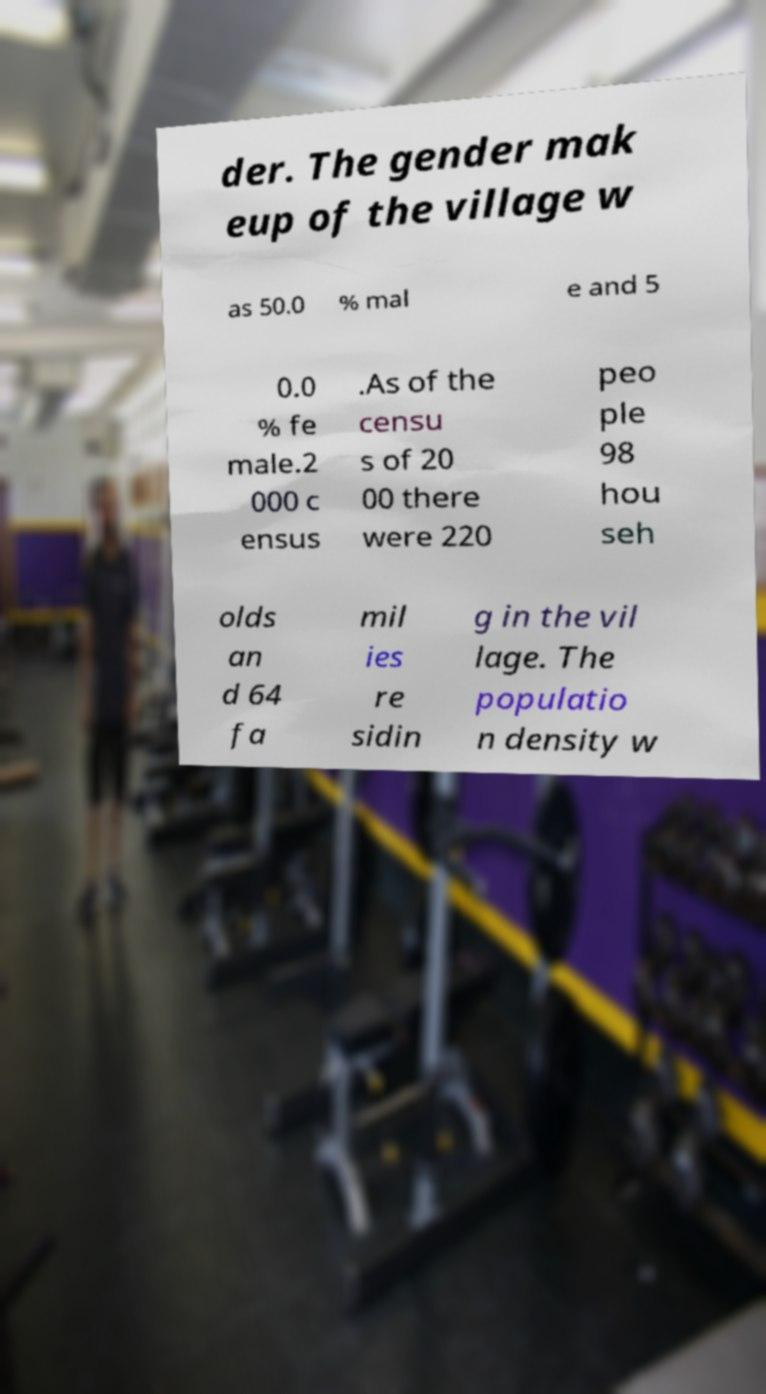Can you read and provide the text displayed in the image?This photo seems to have some interesting text. Can you extract and type it out for me? der. The gender mak eup of the village w as 50.0 % mal e and 5 0.0 % fe male.2 000 c ensus .As of the censu s of 20 00 there were 220 peo ple 98 hou seh olds an d 64 fa mil ies re sidin g in the vil lage. The populatio n density w 